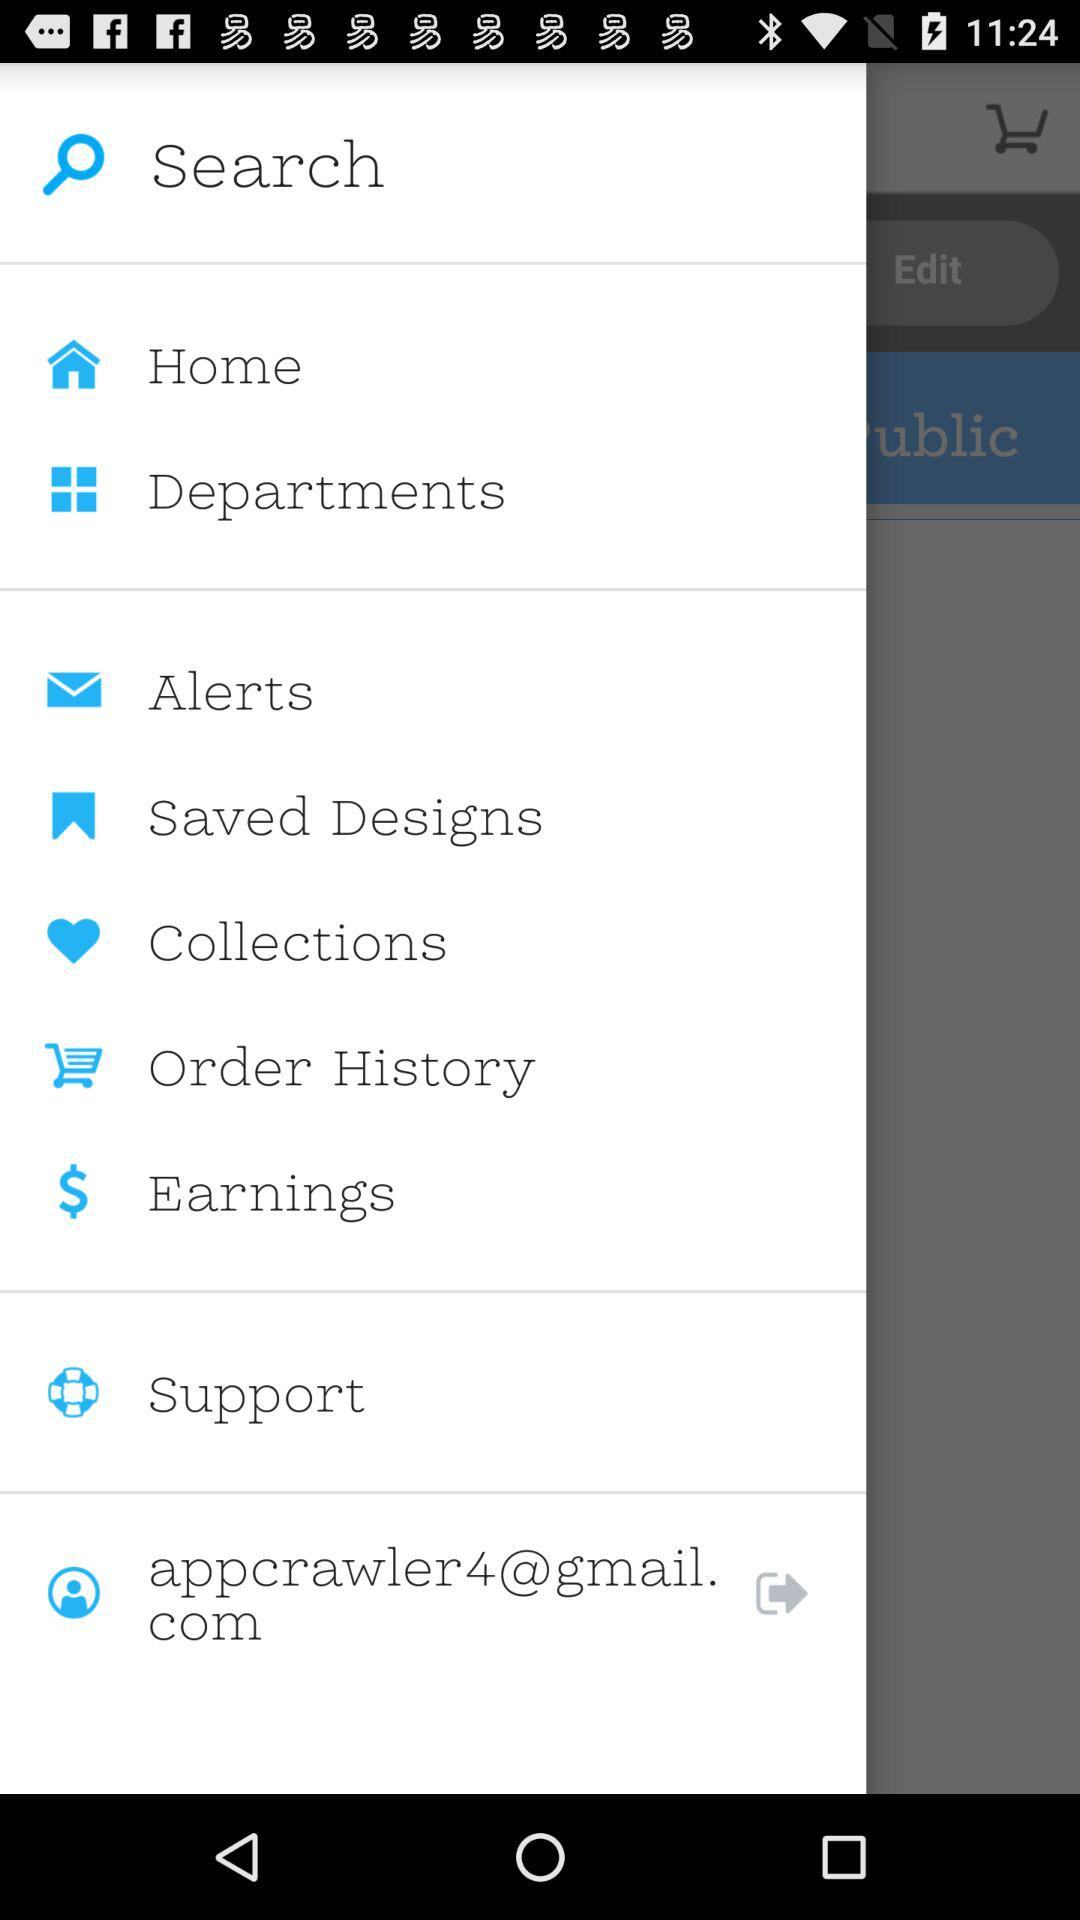What is the email address? The email address is appcrawler4@gmail.com. 